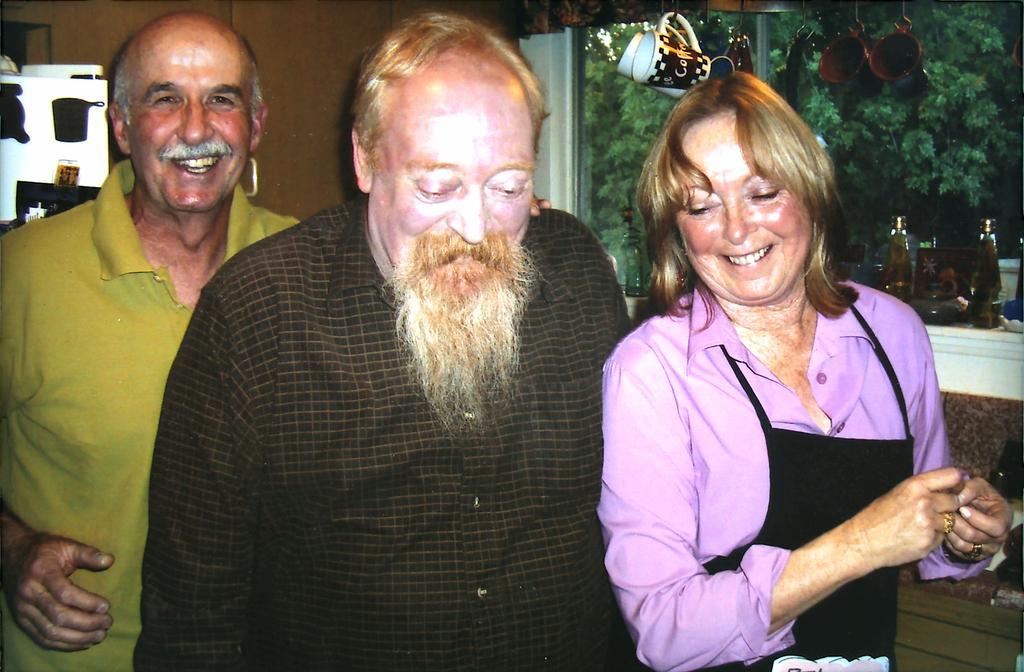In one or two sentences, can you explain what this image depicts? In the center of the image there are three persons. In the background of the image there is wall. To the right side of the image there is a glass window through which we can see trees. There are bottles and mugs hanged to the right side of the image. 